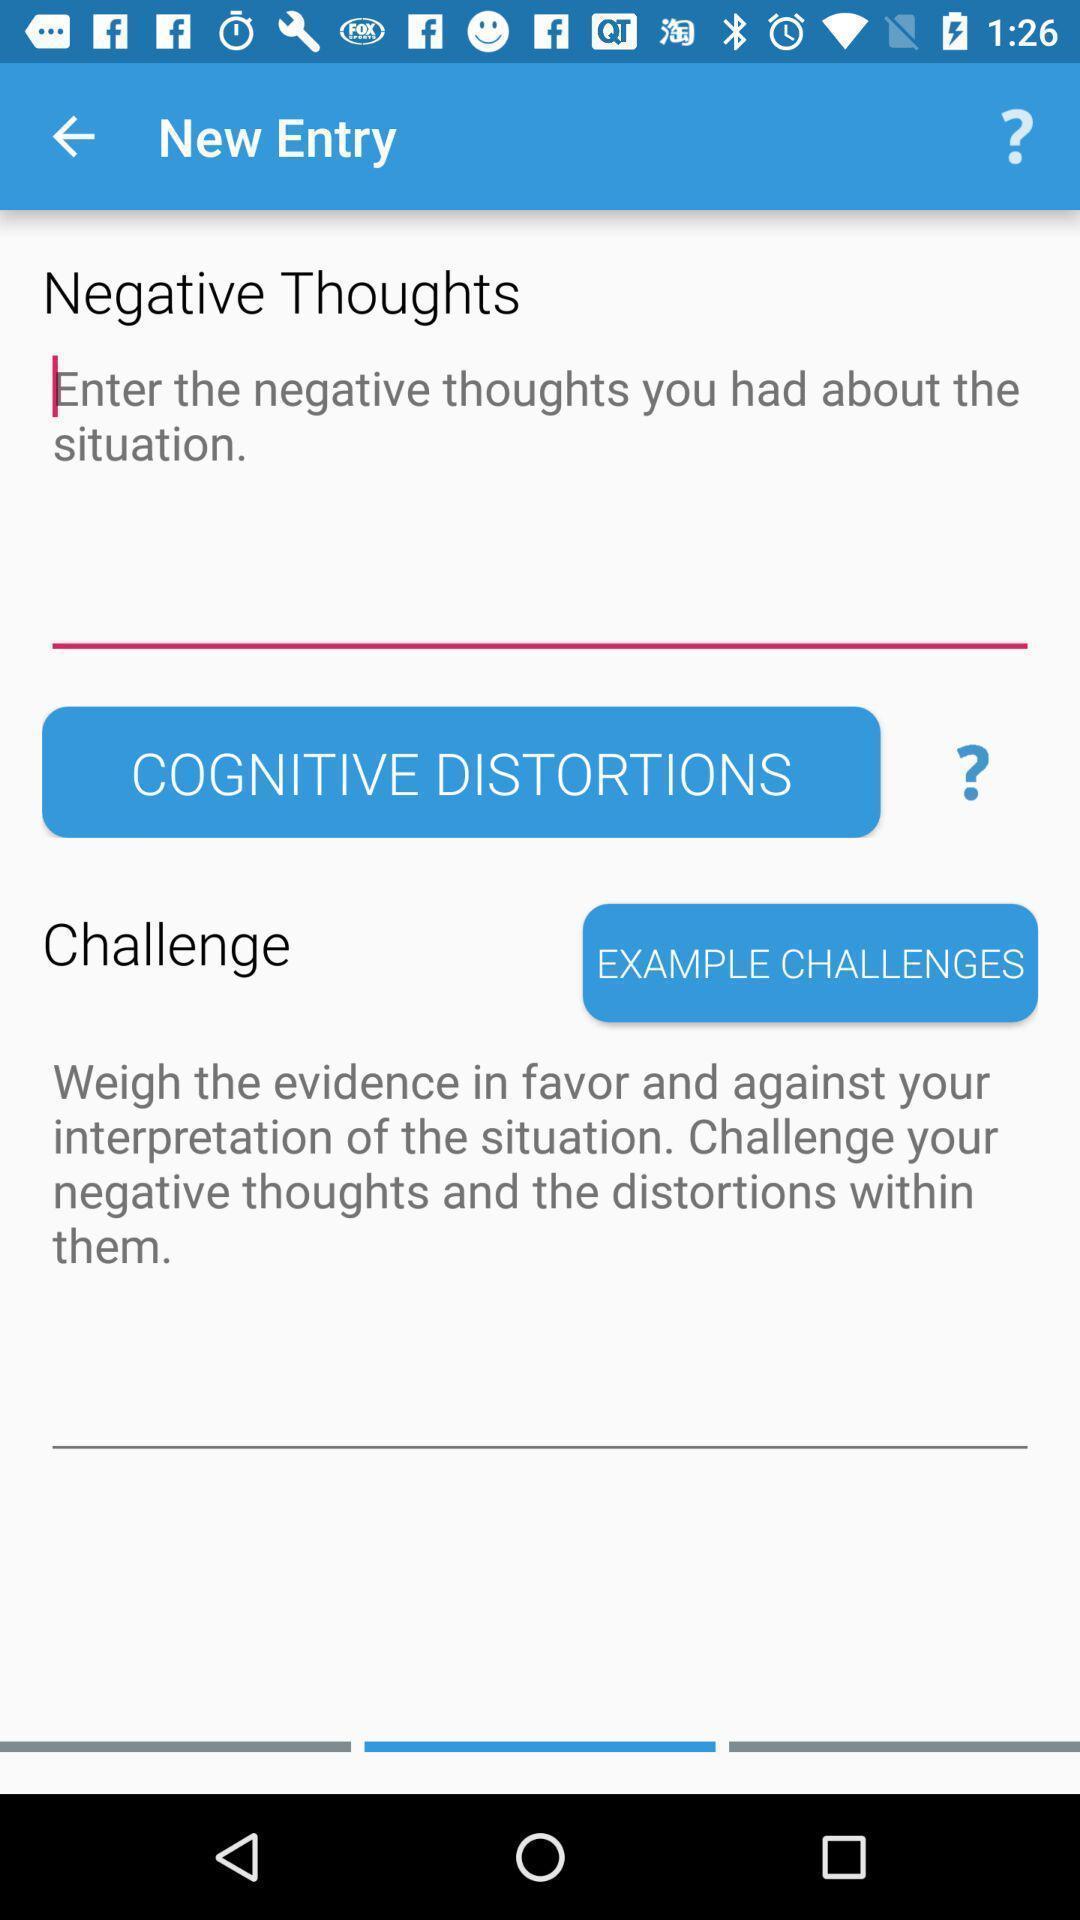Tell me about the visual elements in this screen capture. Screen showing the field to fill the negative thoughts. 